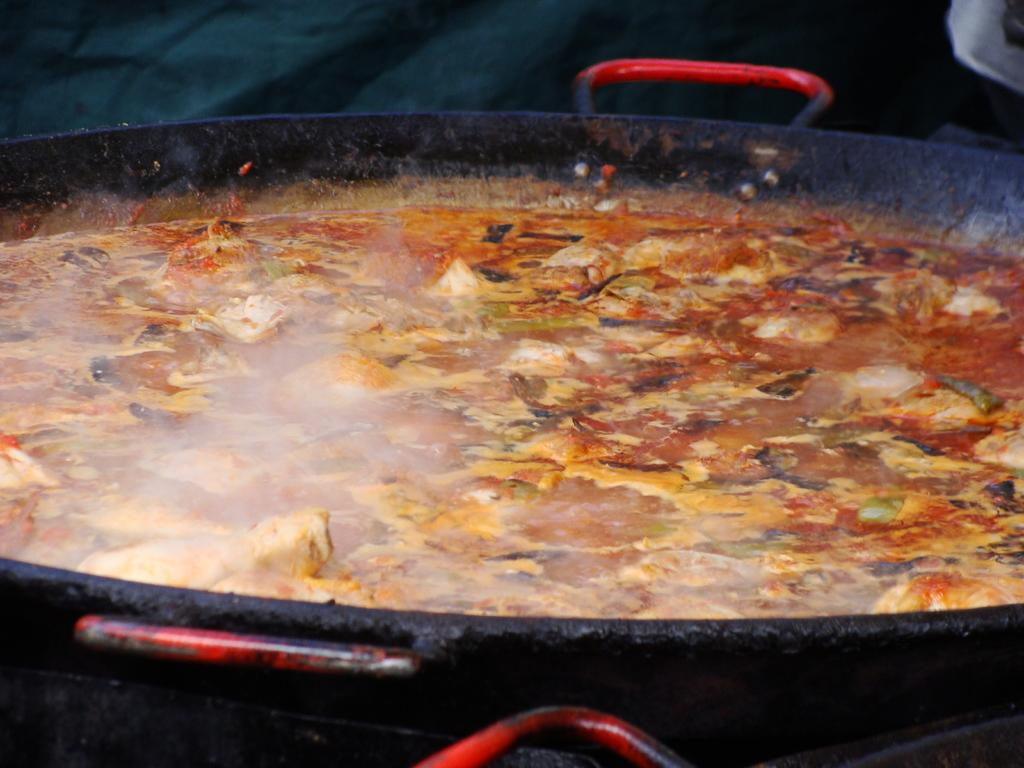What is happening to the food item in the image? The food item is cooking in a pan in the image. Can you describe the cooking process in the image? The food item is being cooked in a pan, which suggests that heat is being applied to it. What might be the outcome of the cooking process? The food item may become cooked and ready to eat. What type of statement is being made by the pump in the image? There is no pump present in the image, so it is not possible to answer that question. 